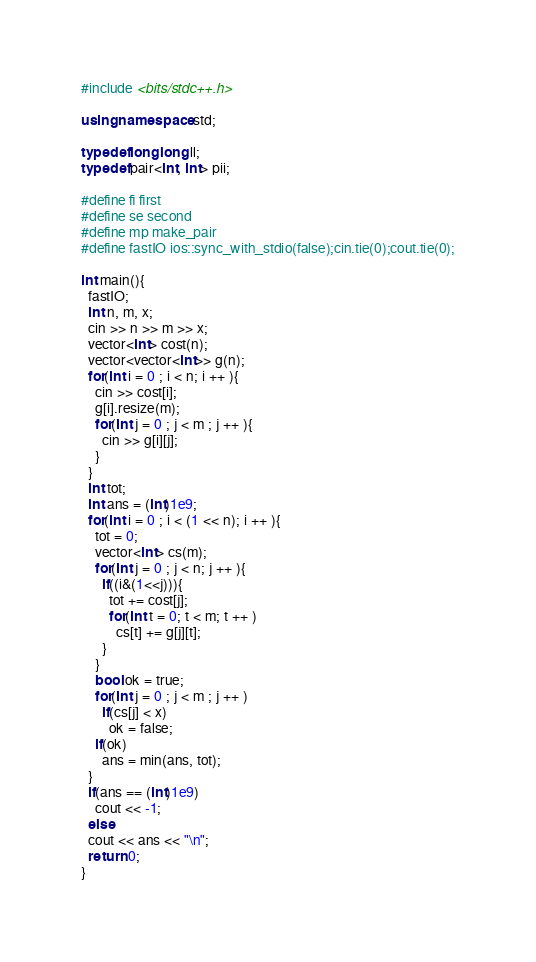<code> <loc_0><loc_0><loc_500><loc_500><_C++_>#include <bits/stdc++.h>

using namespace std;

typedef long long ll;
typedef pair<int, int> pii;

#define fi first
#define se second
#define mp make_pair
#define fastIO ios::sync_with_stdio(false);cin.tie(0);cout.tie(0);

int main(){
  fastIO;
  int n, m, x;
  cin >> n >> m >> x;
  vector<int> cost(n);
  vector<vector<int>> g(n);
  for(int i = 0 ; i < n; i ++ ){
    cin >> cost[i];
    g[i].resize(m);
    for(int j = 0 ; j < m ; j ++ ){
      cin >> g[i][j];
    }
  }
  int tot;
  int ans = (int)1e9;
  for(int i = 0 ; i < (1 << n); i ++ ){
    tot = 0;
    vector<int> cs(m);
    for(int j = 0 ; j < n; j ++ ){
      if((i&(1<<j))){
        tot += cost[j];
        for(int t = 0; t < m; t ++ )
          cs[t] += g[j][t];
      }
    }
    bool ok = true;
    for(int j = 0 ; j < m ; j ++ )
      if(cs[j] < x)
        ok = false;
    if(ok)
      ans = min(ans, tot);
  }
  if(ans == (int)1e9)
    cout << -1;
  else
  cout << ans << "\n";
  return 0;
}</code> 